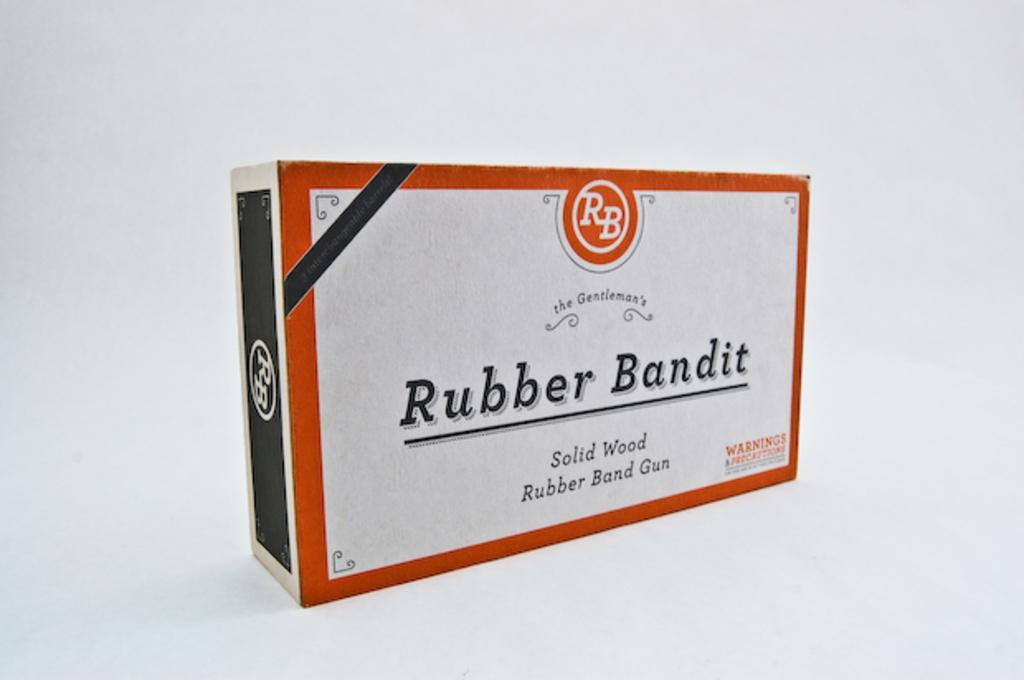<image>
Provide a brief description of the given image. A white, red, and black box of a Rubber Bandit solid wood rubber band gun. 